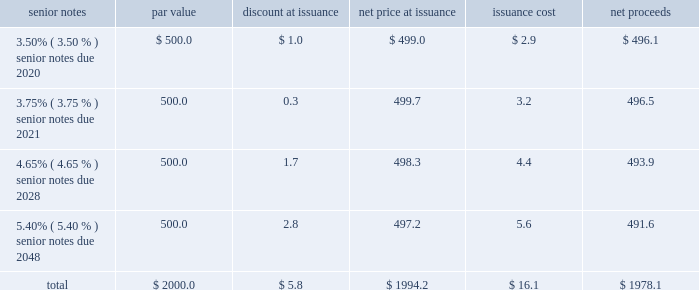Notes to consolidated financial statements 2013 ( continued ) ( amounts in millions , except per share amounts ) debt transactions see note 6 for further information regarding the company 2019s acquisition of acxiom ( the 201cacxiom acquisition 201d ) on october 1 , 2018 ( the 201cclosing date 201d ) .
Senior notes on september 21 , 2018 , in order to fund the acxiom acquisition and related fees and expenses , we issued a total of $ 2000.0 in aggregate principal amount of unsecured senior notes ( in four separate series of $ 500.0 each , together , the 201csenior notes 201d ) .
Upon issuance , the senior notes were reflected on our consolidated balance sheets net of discount of $ 5.8 and net of the capitalized debt issuance costs , including commissions and offering expenses of $ 16.1 , both of which will be amortized in interest expense through the respective maturity dates of each series of senior notes using the effective interest method .
Interest is payable semi-annually in arrears on april 1st and october 1st of each year , commencing on april 1 , 2019 .
The issuance was comprised of the following four series of notes : senior notes par value discount at issuance net price at issuance issuance cost net proceeds .
Consistent with our other debt securities , the newly issued senior notes include covenants that , among other things , limit our liens and the liens of certain of our consolidated subsidiaries , but do not require us to maintain any financial ratios or specified levels of net worth or liquidity .
We may redeem each series of the senior notes at any time in whole or from time to time in part in accordance with the provisions of the indenture , including the applicable supplemental indenture , under which such series of senior notes was issued .
If the acxiom acquisition had been terminated or had not closed on or prior to june 30 , 2019 , we would have been required to redeem the senior notes due 2020 , 2021 and 2028 at a redemption price equal to 101% ( 101 % ) of the principal amount thereof , plus accrued and unpaid interest .
Additionally , upon the occurrence of a change of control repurchase event with respect to the senior notes , each holder of the senior notes has the right to require the company to purchase that holder 2019s senior notes at a price equal to 101% ( 101 % ) of the principal amount thereof , plus accrued and unpaid interest , unless the company has exercised its option to redeem all the senior notes .
Term loan agreement on october 1 , 2018 , in order to fund the acxiom acquisition and related fees and expenses , we borrowed $ 500.0 through debt financing arrangements with third-party lenders under a three-year term loan agreement ( the 201cterm loan agreement 201d ) , $ 100.0 of which we paid down on december 3 , 2018 .
Consistent with our other debt securities , the term loan agreement includes covenants that , among other things , limit our liens and the liens of certain of our consolidated subsidiaries .
In addition , it requires us to maintain the same financial maintenance covenants as discussed below .
Loans under the term loan bear interest at a variable rate based on , at the company 2019s option , either the base rate or the eurodollar rate ( each as defined in the term loan agreement ) plus an applicable margin that is determined based on our credit ratings .
As of december 31 , 2018 , the applicable margin was 0.25% ( 0.25 % ) for base rate loans and 1.25% ( 1.25 % ) for eurodollar rate loans. .
What is the average price at issuance? 
Computations: (1994.2 / 4)
Answer: 498.55. 